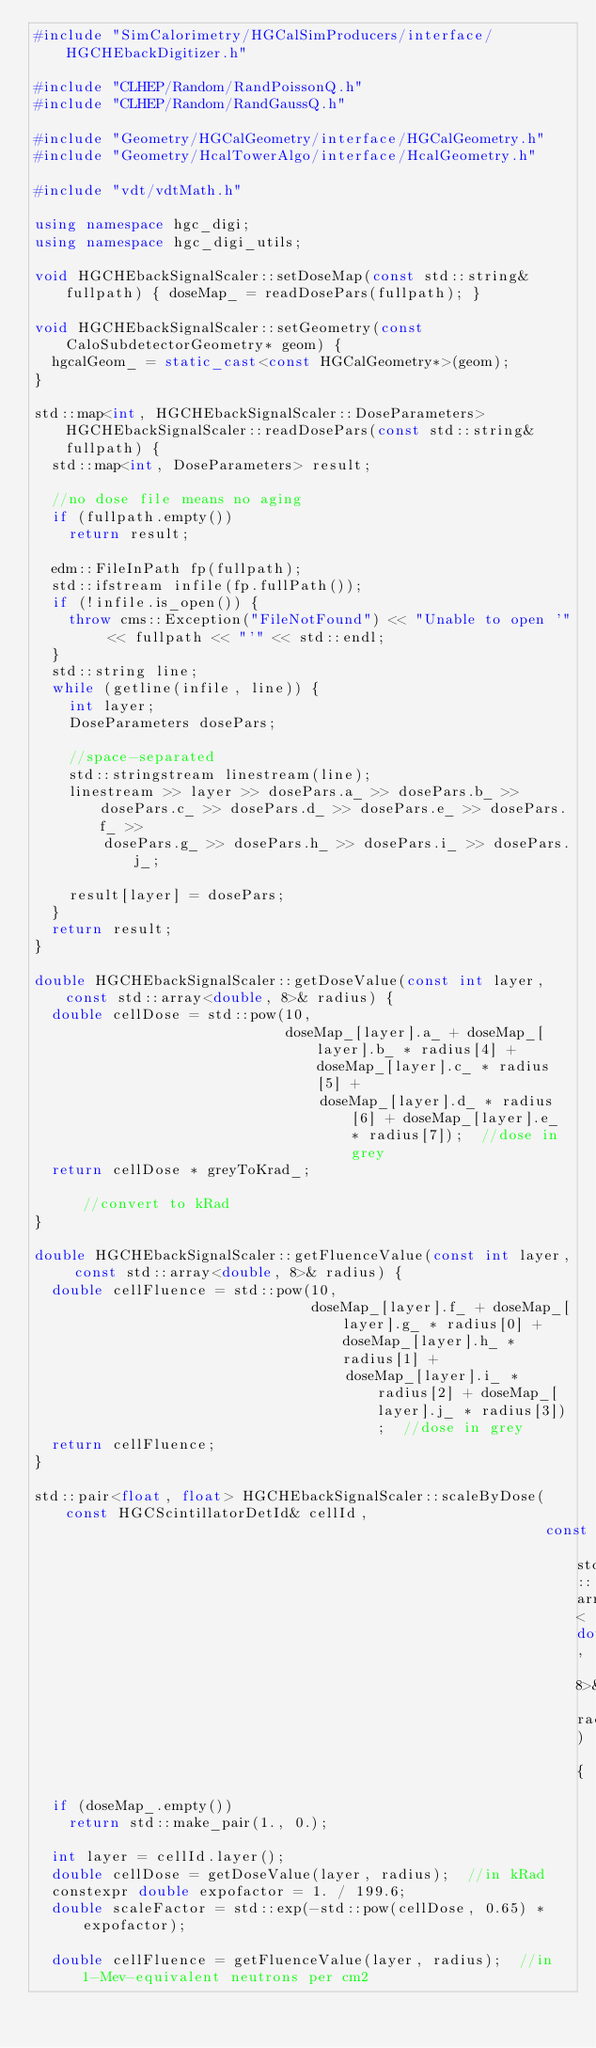Convert code to text. <code><loc_0><loc_0><loc_500><loc_500><_C++_>#include "SimCalorimetry/HGCalSimProducers/interface/HGCHEbackDigitizer.h"

#include "CLHEP/Random/RandPoissonQ.h"
#include "CLHEP/Random/RandGaussQ.h"

#include "Geometry/HGCalGeometry/interface/HGCalGeometry.h"
#include "Geometry/HcalTowerAlgo/interface/HcalGeometry.h"

#include "vdt/vdtMath.h"

using namespace hgc_digi;
using namespace hgc_digi_utils;

void HGCHEbackSignalScaler::setDoseMap(const std::string& fullpath) { doseMap_ = readDosePars(fullpath); }

void HGCHEbackSignalScaler::setGeometry(const CaloSubdetectorGeometry* geom) {
  hgcalGeom_ = static_cast<const HGCalGeometry*>(geom);
}

std::map<int, HGCHEbackSignalScaler::DoseParameters> HGCHEbackSignalScaler::readDosePars(const std::string& fullpath) {
  std::map<int, DoseParameters> result;

  //no dose file means no aging
  if (fullpath.empty())
    return result;

  edm::FileInPath fp(fullpath);
  std::ifstream infile(fp.fullPath());
  if (!infile.is_open()) {
    throw cms::Exception("FileNotFound") << "Unable to open '" << fullpath << "'" << std::endl;
  }
  std::string line;
  while (getline(infile, line)) {
    int layer;
    DoseParameters dosePars;

    //space-separated
    std::stringstream linestream(line);
    linestream >> layer >> dosePars.a_ >> dosePars.b_ >> dosePars.c_ >> dosePars.d_ >> dosePars.e_ >> dosePars.f_ >>
        dosePars.g_ >> dosePars.h_ >> dosePars.i_ >> dosePars.j_;

    result[layer] = dosePars;
  }
  return result;
}

double HGCHEbackSignalScaler::getDoseValue(const int layer, const std::array<double, 8>& radius) {
  double cellDose = std::pow(10,
                             doseMap_[layer].a_ + doseMap_[layer].b_ * radius[4] + doseMap_[layer].c_ * radius[5] +
                                 doseMap_[layer].d_ * radius[6] + doseMap_[layer].e_ * radius[7]);  //dose in grey
  return cellDose * greyToKrad_;                                                                    //convert to kRad
}

double HGCHEbackSignalScaler::getFluenceValue(const int layer, const std::array<double, 8>& radius) {
  double cellFluence = std::pow(10,
                                doseMap_[layer].f_ + doseMap_[layer].g_ * radius[0] + doseMap_[layer].h_ * radius[1] +
                                    doseMap_[layer].i_ * radius[2] + doseMap_[layer].j_ * radius[3]);  //dose in grey
  return cellFluence;
}

std::pair<float, float> HGCHEbackSignalScaler::scaleByDose(const HGCScintillatorDetId& cellId,
                                                           const std::array<double, 8>& radius) {
  if (doseMap_.empty())
    return std::make_pair(1., 0.);

  int layer = cellId.layer();
  double cellDose = getDoseValue(layer, radius);  //in kRad
  constexpr double expofactor = 1. / 199.6;
  double scaleFactor = std::exp(-std::pow(cellDose, 0.65) * expofactor);

  double cellFluence = getFluenceValue(layer, radius);  //in 1-Mev-equivalent neutrons per cm2
</code> 